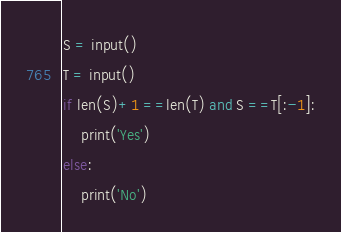Convert code to text. <code><loc_0><loc_0><loc_500><loc_500><_Python_>S = input()
T = input()
if len(S)+1 ==len(T) and S ==T[:-1]:
    print('Yes')
else:
    print('No')</code> 